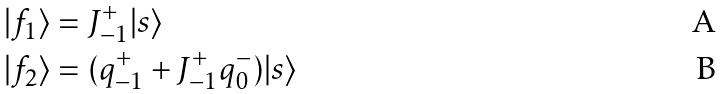Convert formula to latex. <formula><loc_0><loc_0><loc_500><loc_500>| f _ { 1 } \rangle & = J _ { - 1 } ^ { + } | s \rangle \\ | f _ { 2 } \rangle & = ( q _ { - 1 } ^ { + } + J _ { - 1 } ^ { + } q _ { 0 } ^ { - } ) | s \rangle</formula> 